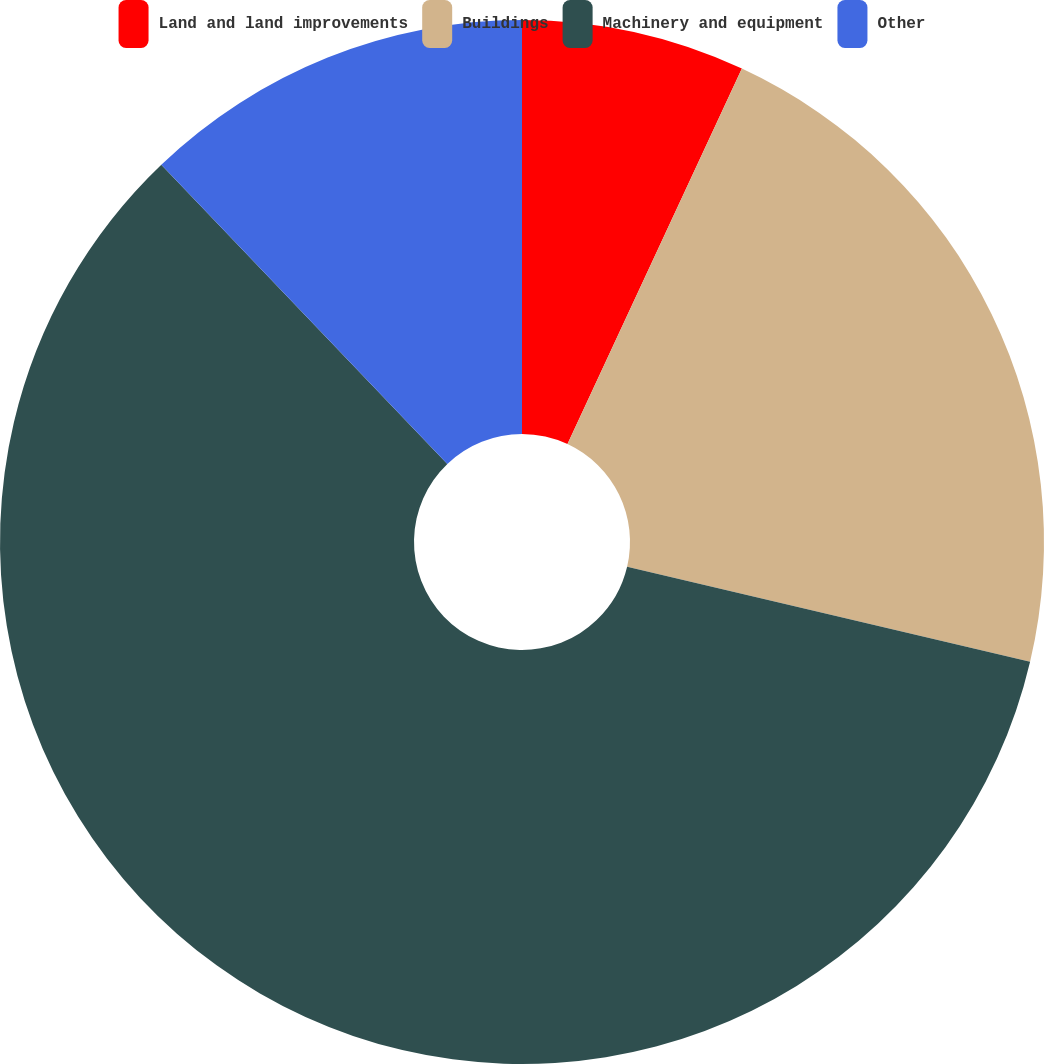<chart> <loc_0><loc_0><loc_500><loc_500><pie_chart><fcel>Land and land improvements<fcel>Buildings<fcel>Machinery and equipment<fcel>Other<nl><fcel>6.92%<fcel>21.76%<fcel>59.17%<fcel>12.14%<nl></chart> 